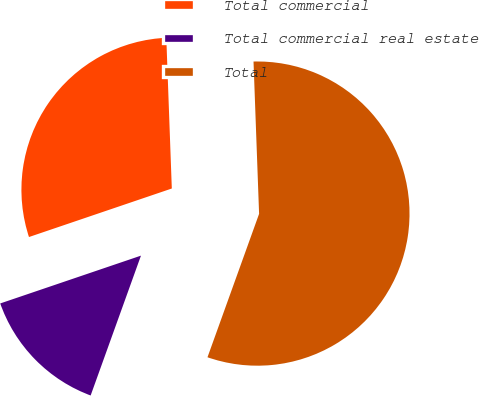Convert chart to OTSL. <chart><loc_0><loc_0><loc_500><loc_500><pie_chart><fcel>Total commercial<fcel>Total commercial real estate<fcel>Total<nl><fcel>29.63%<fcel>14.29%<fcel>56.08%<nl></chart> 